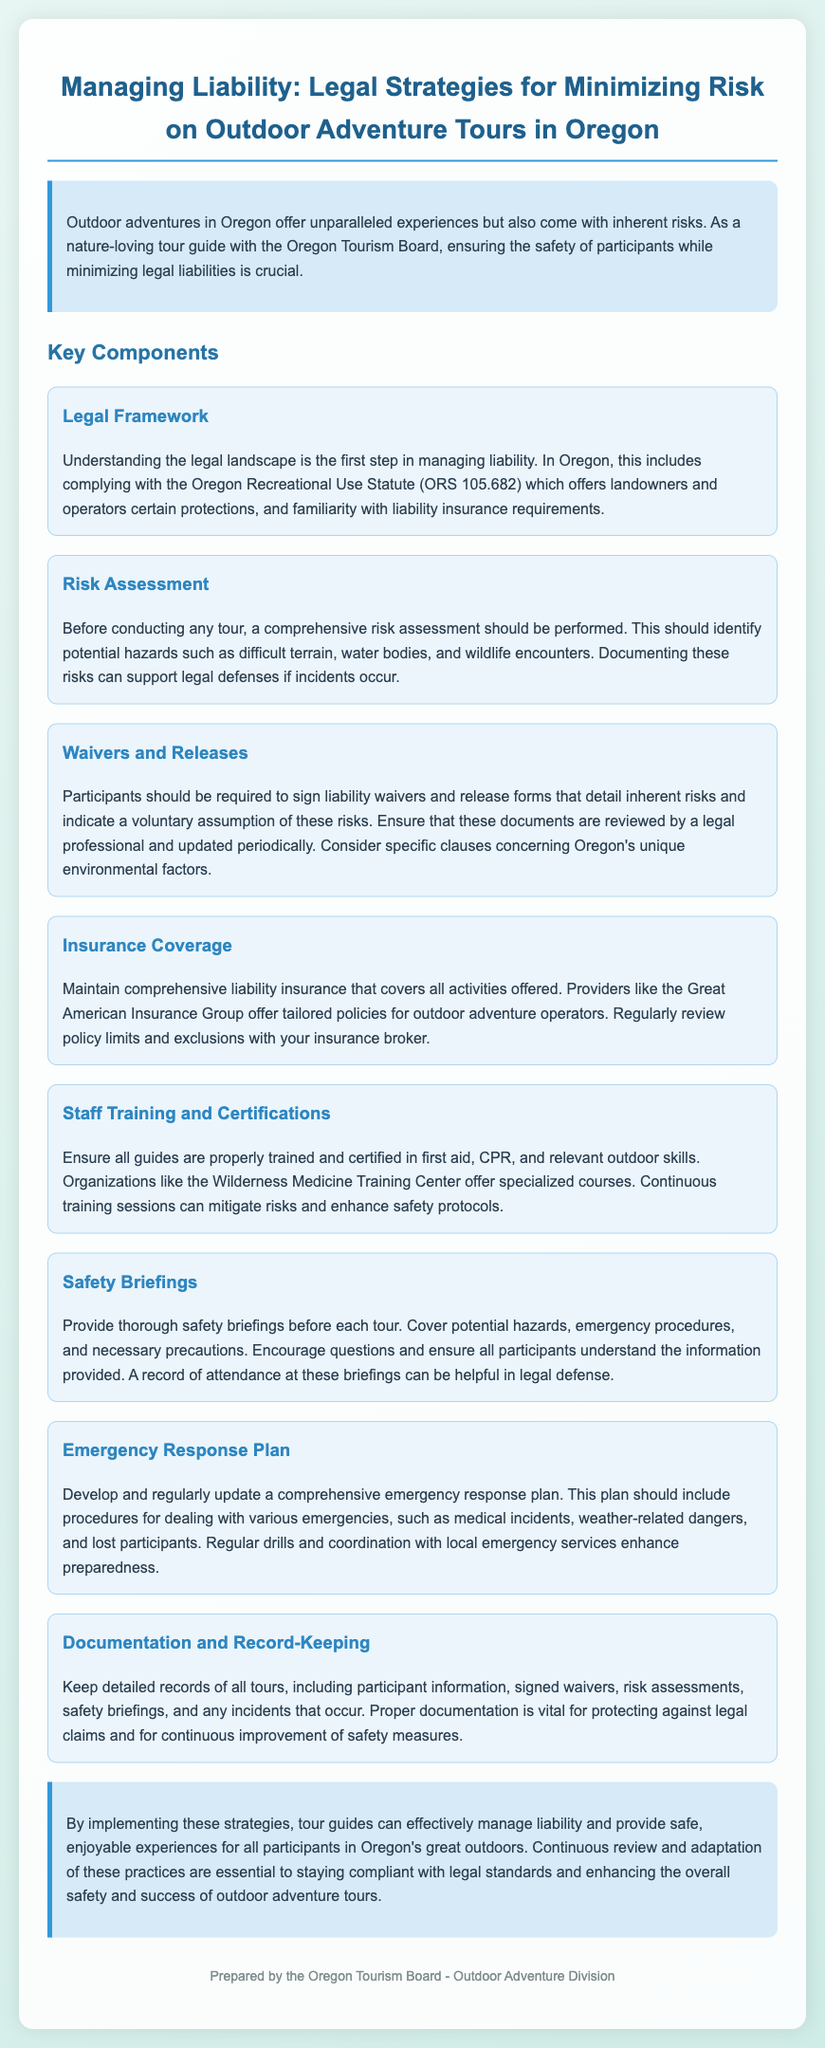what is the title of the document? The title is listed at the top of the rendered document, encapsulating the primary focus of the contents.
Answer: Managing Liability: Legal Strategies for Minimizing Risk on Outdoor Adventure Tours in Oregon what is the first key component discussed? The document lists various key components, with the first one specifically addressing legal aspects related to liability.
Answer: Legal Framework what does the waiver and release form detail? This form is crucial in informing participants of inherent risks involved in outdoor activities and ensuring their voluntary acceptance.
Answer: Inherent risks what type of insurance is recommended? The document emphasizes the necessity of a certain type of insurance that specifically caters to outdoor operation risks.
Answer: Liability insurance how often should safety briefings be conducted? Safety briefings should take place before each tour, providing essential information to participants for their safety.
Answer: Before each tour what should be included in the emergency response plan? This vital plan outlines procedures for various emergency scenarios that may occur during outdoor activities.
Answer: Procedures for emergencies which organization offers specialized training courses for staff? A specific organization is mentioned that focuses on providing essential training relevant to outdoor adventure operations.
Answer: Wilderness Medicine Training Center how can documentation help in legal claims? Keeping thorough documentation can provide crucial evidence in the event of any legal issues arising following outdoor tours.
Answer: Protecting against legal claims who prepared the document? The authorship of the document is clearly stated at the end, attributing the responsibility to a specific division.
Answer: Oregon Tourism Board - Outdoor Adventure Division 